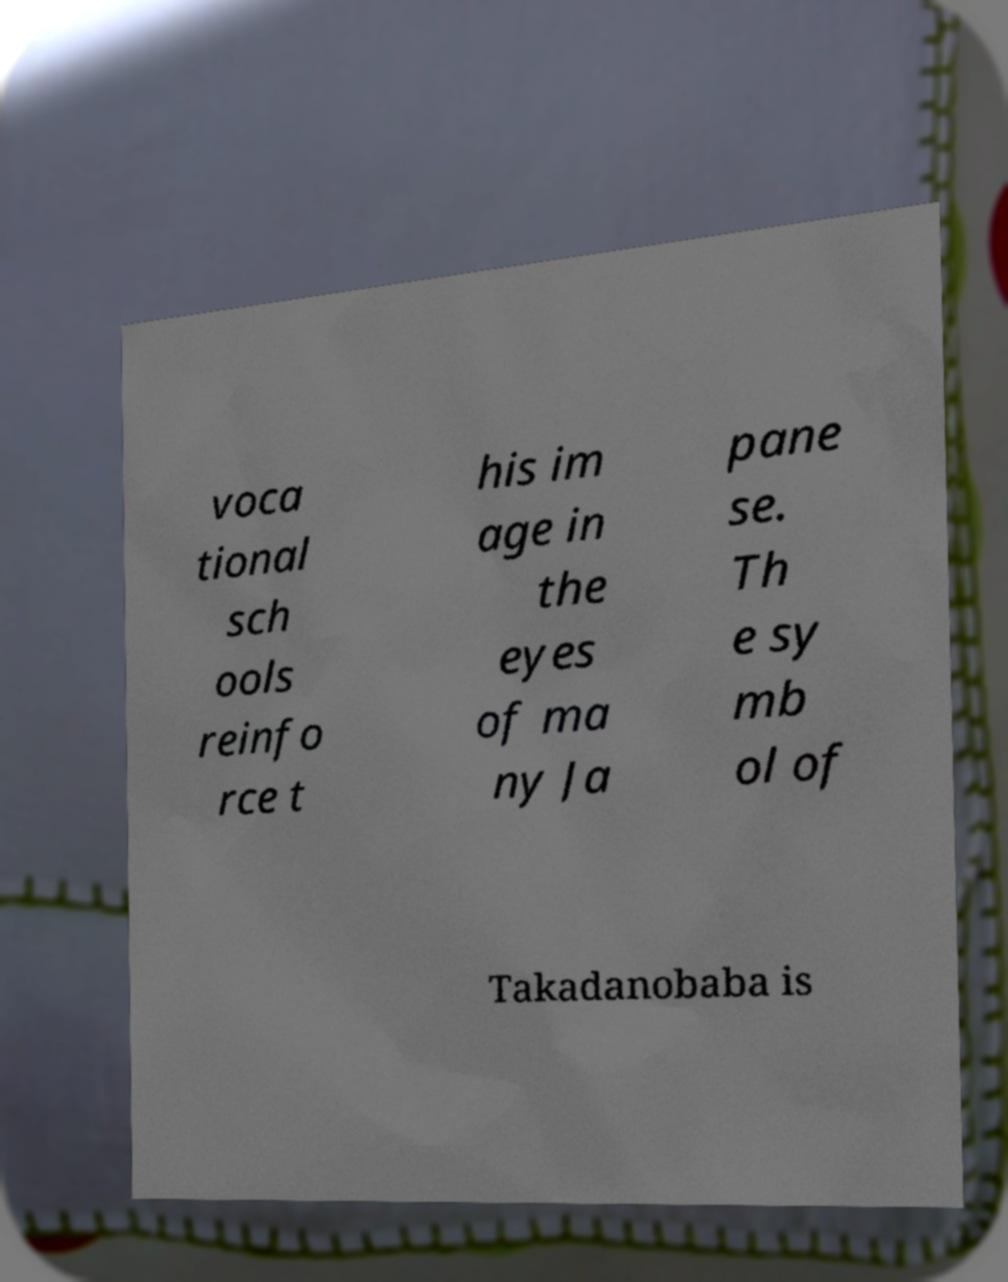I need the written content from this picture converted into text. Can you do that? voca tional sch ools reinfo rce t his im age in the eyes of ma ny Ja pane se. Th e sy mb ol of Takadanobaba is 